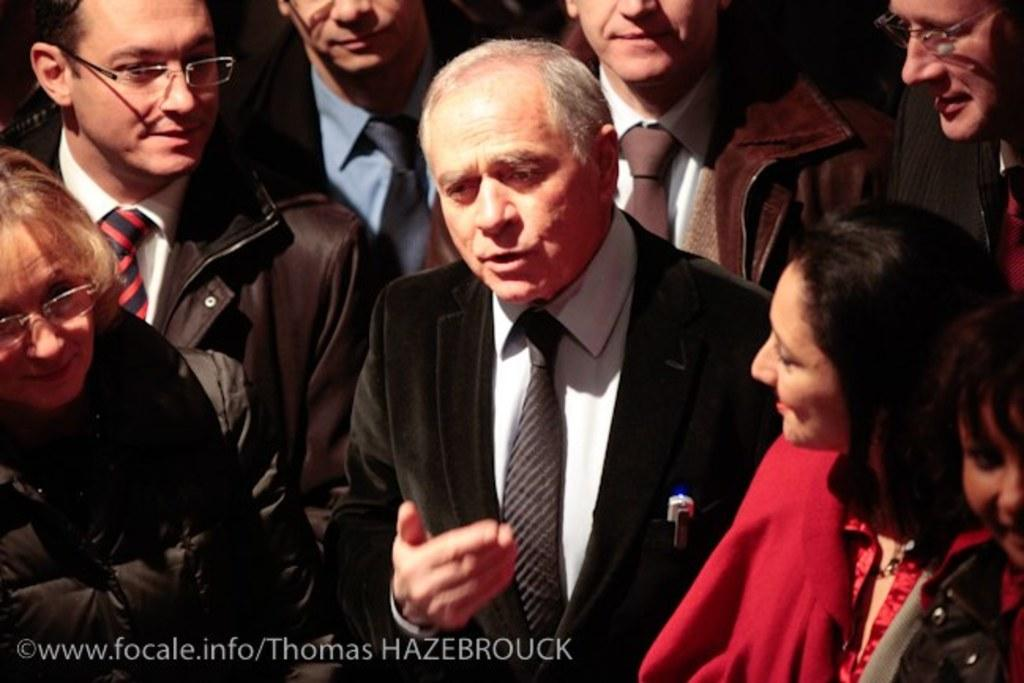What is the main action taking place in the image? There is a person speaking in the image. Are there any other people present in the image? Yes, there are other people around the person speaking. What type of birds can be seen flying in a square formation in the image? There are no birds or squares present in the image; it features a person speaking with other people around them. 